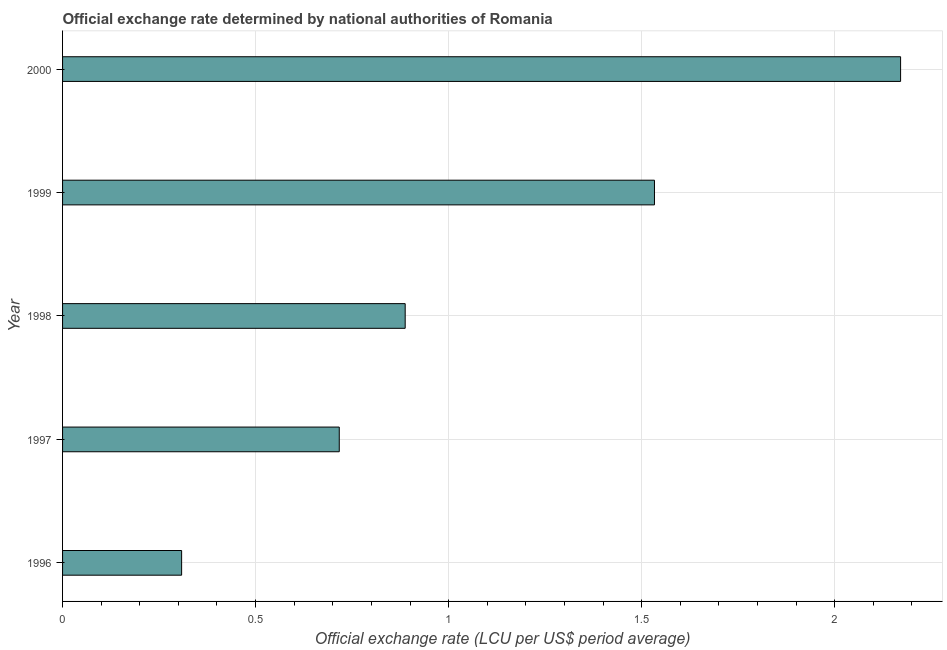What is the title of the graph?
Your answer should be very brief. Official exchange rate determined by national authorities of Romania. What is the label or title of the X-axis?
Provide a succinct answer. Official exchange rate (LCU per US$ period average). What is the official exchange rate in 2000?
Provide a short and direct response. 2.17. Across all years, what is the maximum official exchange rate?
Give a very brief answer. 2.17. Across all years, what is the minimum official exchange rate?
Offer a very short reply. 0.31. In which year was the official exchange rate minimum?
Ensure brevity in your answer.  1996. What is the sum of the official exchange rate?
Offer a very short reply. 5.62. What is the difference between the official exchange rate in 1997 and 1998?
Make the answer very short. -0.17. What is the average official exchange rate per year?
Offer a terse response. 1.12. What is the median official exchange rate?
Offer a terse response. 0.89. Do a majority of the years between 1999 and 2000 (inclusive) have official exchange rate greater than 1.2 ?
Provide a short and direct response. Yes. What is the ratio of the official exchange rate in 1997 to that in 1998?
Your answer should be compact. 0.81. Is the official exchange rate in 1997 less than that in 1999?
Your answer should be compact. Yes. Is the difference between the official exchange rate in 1996 and 1998 greater than the difference between any two years?
Provide a succinct answer. No. What is the difference between the highest and the second highest official exchange rate?
Offer a very short reply. 0.64. Is the sum of the official exchange rate in 1999 and 2000 greater than the maximum official exchange rate across all years?
Make the answer very short. Yes. What is the difference between the highest and the lowest official exchange rate?
Your answer should be compact. 1.86. Are the values on the major ticks of X-axis written in scientific E-notation?
Your answer should be compact. No. What is the Official exchange rate (LCU per US$ period average) in 1996?
Keep it short and to the point. 0.31. What is the Official exchange rate (LCU per US$ period average) in 1997?
Offer a very short reply. 0.72. What is the Official exchange rate (LCU per US$ period average) in 1998?
Your response must be concise. 0.89. What is the Official exchange rate (LCU per US$ period average) in 1999?
Your response must be concise. 1.53. What is the Official exchange rate (LCU per US$ period average) of 2000?
Make the answer very short. 2.17. What is the difference between the Official exchange rate (LCU per US$ period average) in 1996 and 1997?
Offer a terse response. -0.41. What is the difference between the Official exchange rate (LCU per US$ period average) in 1996 and 1998?
Keep it short and to the point. -0.58. What is the difference between the Official exchange rate (LCU per US$ period average) in 1996 and 1999?
Offer a terse response. -1.22. What is the difference between the Official exchange rate (LCU per US$ period average) in 1996 and 2000?
Offer a very short reply. -1.86. What is the difference between the Official exchange rate (LCU per US$ period average) in 1997 and 1998?
Keep it short and to the point. -0.17. What is the difference between the Official exchange rate (LCU per US$ period average) in 1997 and 1999?
Provide a succinct answer. -0.82. What is the difference between the Official exchange rate (LCU per US$ period average) in 1997 and 2000?
Your answer should be compact. -1.45. What is the difference between the Official exchange rate (LCU per US$ period average) in 1998 and 1999?
Your answer should be very brief. -0.65. What is the difference between the Official exchange rate (LCU per US$ period average) in 1998 and 2000?
Give a very brief answer. -1.28. What is the difference between the Official exchange rate (LCU per US$ period average) in 1999 and 2000?
Make the answer very short. -0.64. What is the ratio of the Official exchange rate (LCU per US$ period average) in 1996 to that in 1997?
Ensure brevity in your answer.  0.43. What is the ratio of the Official exchange rate (LCU per US$ period average) in 1996 to that in 1998?
Your answer should be very brief. 0.35. What is the ratio of the Official exchange rate (LCU per US$ period average) in 1996 to that in 1999?
Your response must be concise. 0.2. What is the ratio of the Official exchange rate (LCU per US$ period average) in 1996 to that in 2000?
Your answer should be very brief. 0.14. What is the ratio of the Official exchange rate (LCU per US$ period average) in 1997 to that in 1998?
Provide a short and direct response. 0.81. What is the ratio of the Official exchange rate (LCU per US$ period average) in 1997 to that in 1999?
Keep it short and to the point. 0.47. What is the ratio of the Official exchange rate (LCU per US$ period average) in 1997 to that in 2000?
Keep it short and to the point. 0.33. What is the ratio of the Official exchange rate (LCU per US$ period average) in 1998 to that in 1999?
Offer a terse response. 0.58. What is the ratio of the Official exchange rate (LCU per US$ period average) in 1998 to that in 2000?
Provide a short and direct response. 0.41. What is the ratio of the Official exchange rate (LCU per US$ period average) in 1999 to that in 2000?
Keep it short and to the point. 0.71. 